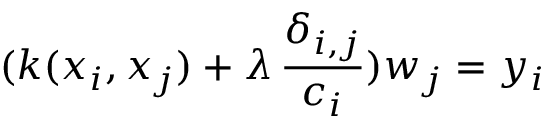Convert formula to latex. <formula><loc_0><loc_0><loc_500><loc_500>( k ( x _ { i } , x _ { j } ) + \lambda \, \frac { \delta _ { i , j } } { c _ { i } } ) w _ { j } = y _ { i }</formula> 